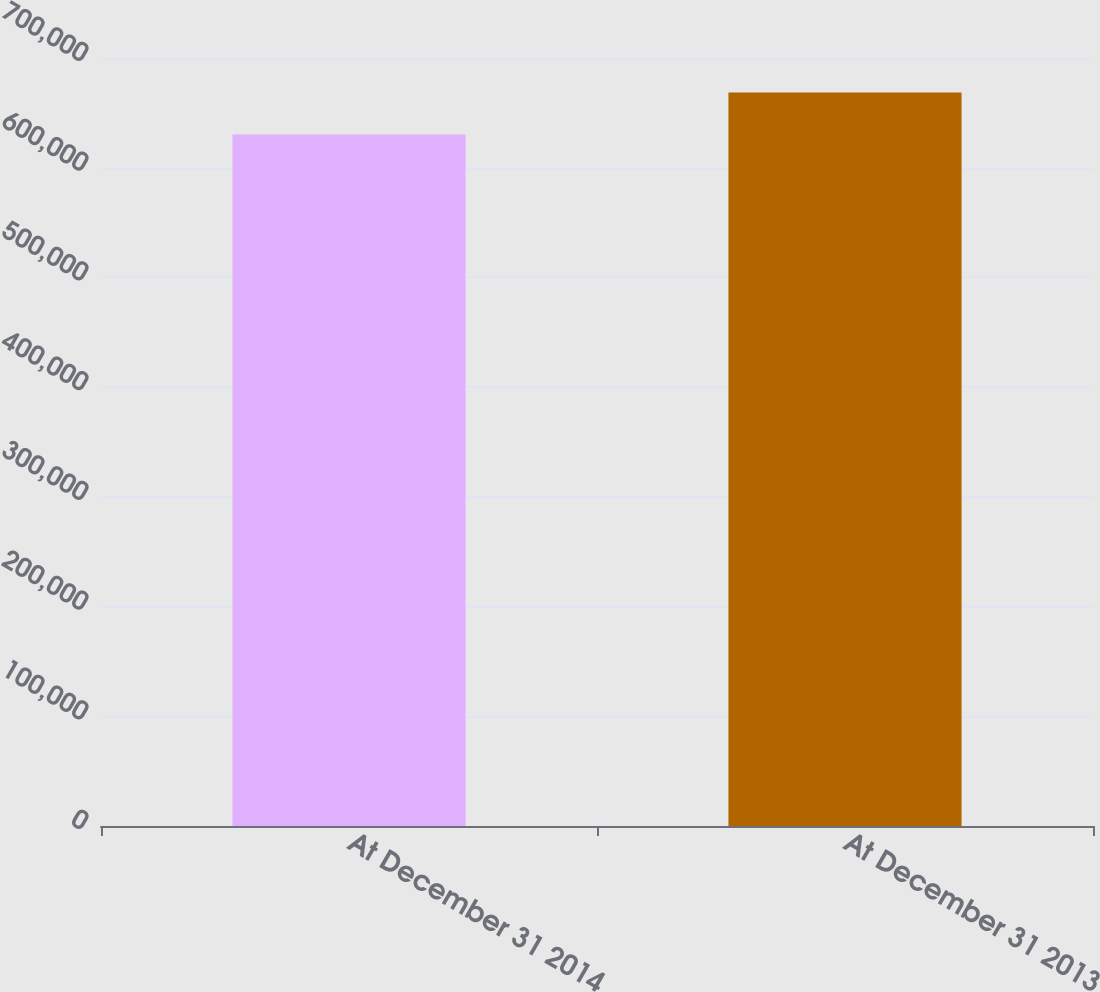Convert chart to OTSL. <chart><loc_0><loc_0><loc_500><loc_500><bar_chart><fcel>At December 31 2014<fcel>At December 31 2013<nl><fcel>630341<fcel>668596<nl></chart> 